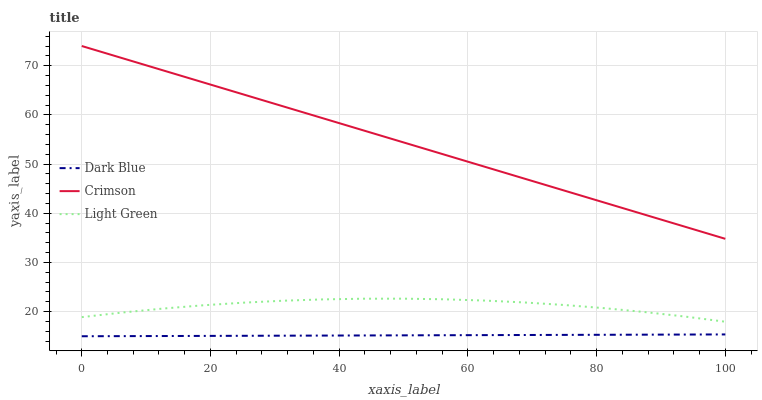Does Dark Blue have the minimum area under the curve?
Answer yes or no. Yes. Does Crimson have the maximum area under the curve?
Answer yes or no. Yes. Does Light Green have the minimum area under the curve?
Answer yes or no. No. Does Light Green have the maximum area under the curve?
Answer yes or no. No. Is Dark Blue the smoothest?
Answer yes or no. Yes. Is Light Green the roughest?
Answer yes or no. Yes. Is Light Green the smoothest?
Answer yes or no. No. Is Dark Blue the roughest?
Answer yes or no. No. Does Dark Blue have the lowest value?
Answer yes or no. Yes. Does Light Green have the lowest value?
Answer yes or no. No. Does Crimson have the highest value?
Answer yes or no. Yes. Does Light Green have the highest value?
Answer yes or no. No. Is Light Green less than Crimson?
Answer yes or no. Yes. Is Light Green greater than Dark Blue?
Answer yes or no. Yes. Does Light Green intersect Crimson?
Answer yes or no. No. 